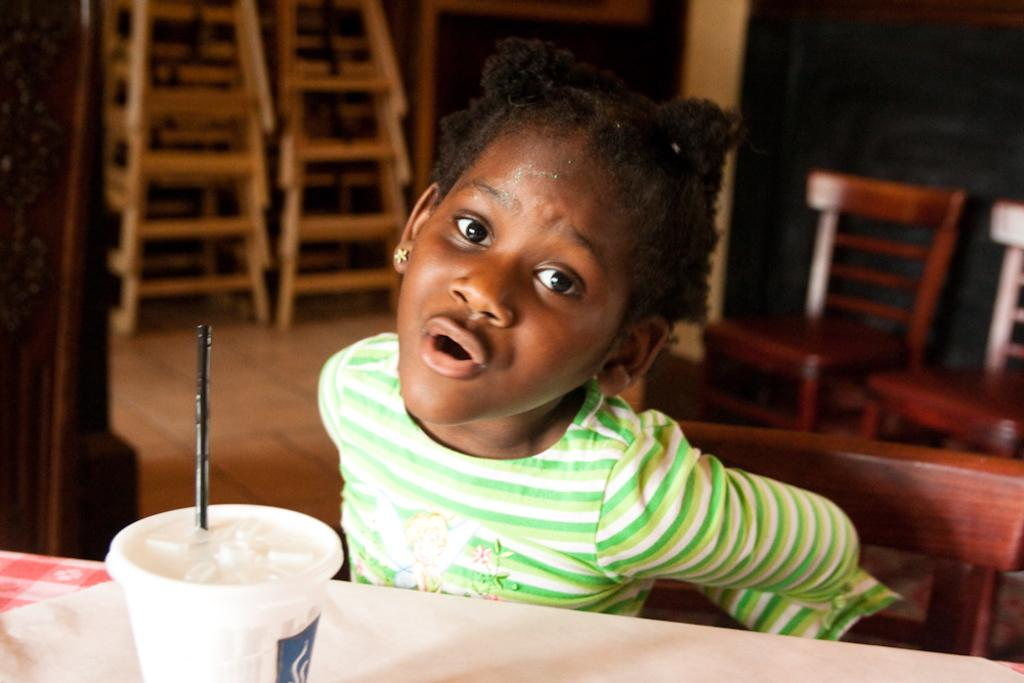What is the main subject of the image? There is a child in the image. What is the child doing in the image? The child is sitting on a chair. Where is the chair located in relation to the table? The chair is near a table. What is on the table? There is a glass on the table, and it contains a drink. How is the drink being consumed? There is a straw in the glass, which suggests the drink is being sipped. What can be seen in the background of the image? There are chairs and a stand in the background of the image. Can you see any cobwebs in the image? There is no mention of cobwebs in the provided facts, so it cannot be determined if any are present in the image. What is being crushed in the image? There is no indication of anything being crushed in the image. 